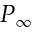<formula> <loc_0><loc_0><loc_500><loc_500>P _ { \infty }</formula> 